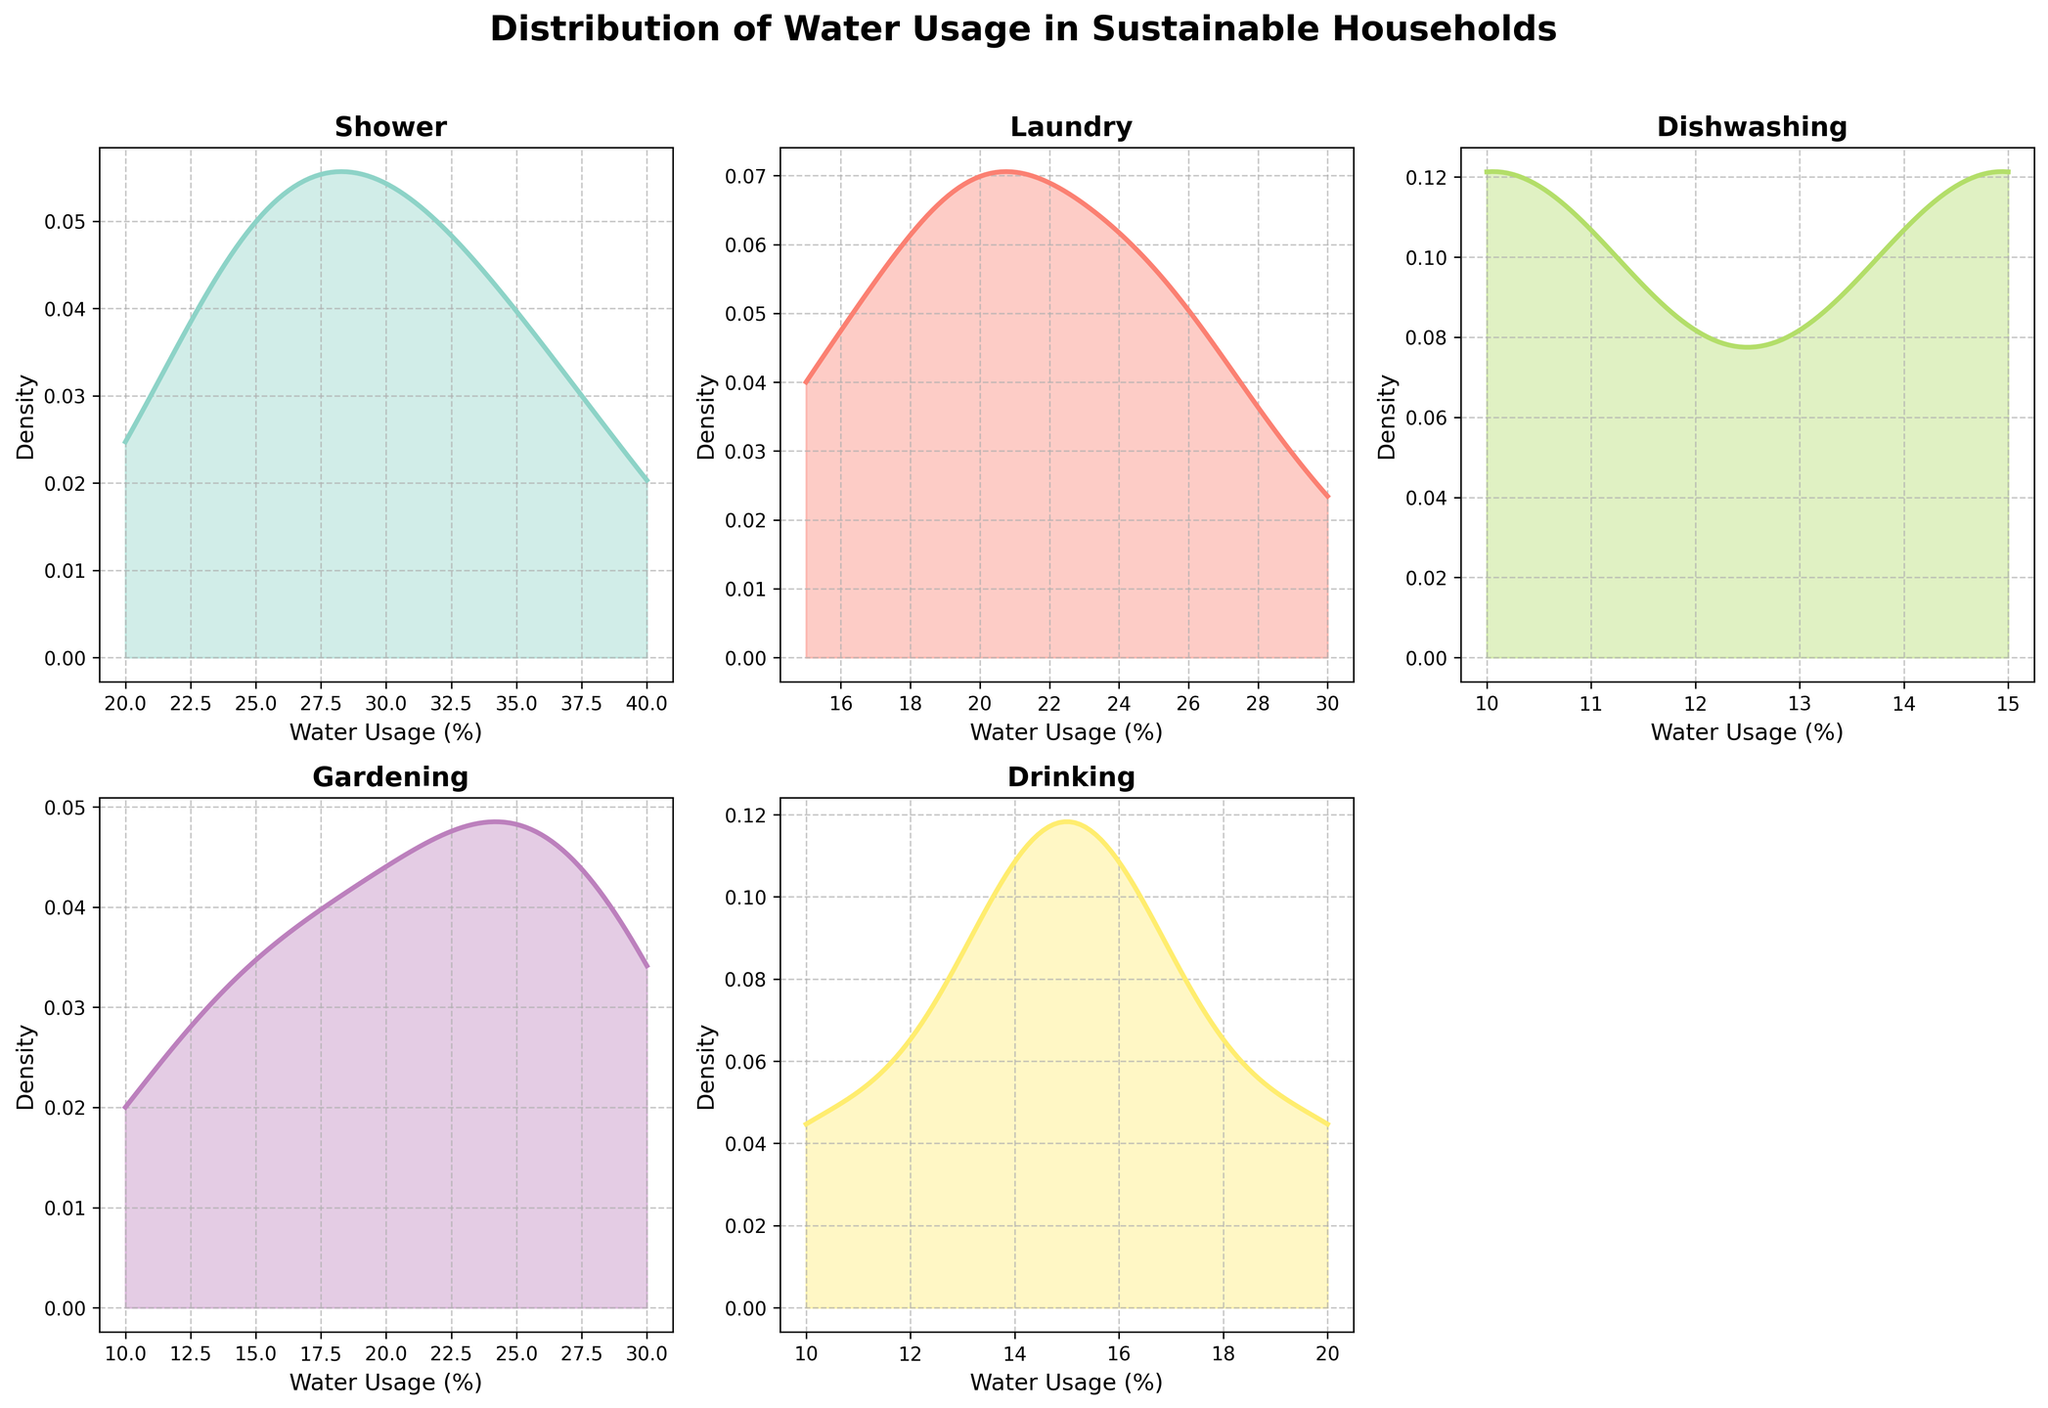What's the title of the figure? The title of the figure is usually found at the top of the plot. In this case, it is "Distribution of Water Usage in Sustainable Households".
Answer: Distribution of Water Usage in Sustainable Households How many categories of water usage are shown in the figure? We can count the number of subplots or the number of titles on each subplot to determine the number of categories. There are six subplots, each representing a different category.
Answer: Six Which category shows a peak in density around 30% water usage? By examining each subplot, we find that the category "Shower" shows a peak around 30% water usage.
Answer: Shower What is the range of water usage values considered in the 'Gardening' category? By looking at the x-axis of the 'Gardening' subplot, the water usage values range from 10% to 30%.
Answer: 10% to 30% Which category has the lowest variation in water usage distribution? To determine this, we look for the category with the narrowest spread in density. "Dishwashing" has the lowest variation, with density concentrated around 10% and 15%.
Answer: Dishwashing Compare the peak density values of 'Laundry' and 'Gardening'. Which one is higher? By examining the density peaks in both subplots, 'Laundry' shows a higher peak density compared to 'Gardening'.
Answer: Laundry What's the most common water usage percentage for 'Drinking' water? By finding the highest peak in the 'Drinking' subplot, we see that it is around 15% water usage.
Answer: 15% For the 'Shower' category, what is the approximate density value at 35% water usage? By looking at the density curve for the 'Shower' category at 35% on the x-axis, we approximate the density value to be around 0.05 based on the y-axis.
Answer: 0.05 Which category appears to have a bimodal distribution? We look for a subplot with two peaks in the density curve. 'Laundry' shows two distinct peaks, indicating a bimodal distribution.
Answer: Laundry If we average the peak water usage values of 'Shower', 'Laundry', and 'Gardening', what do we get? The peak water usage for "Shower" is around 30%, for "Laundry" it is around 25%, and for "Gardening" it is around 25%. Averaging these, we get (30% + 25% + 25%) / 3 = 26.67%.
Answer: 26.67% 